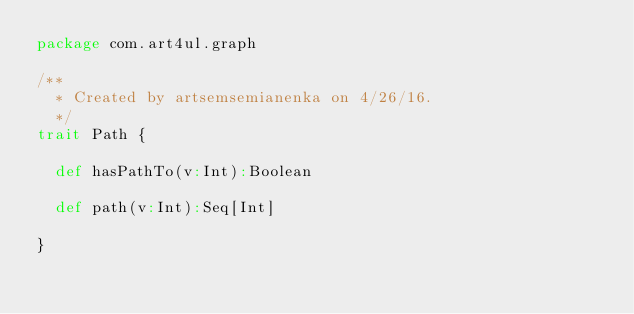Convert code to text. <code><loc_0><loc_0><loc_500><loc_500><_Scala_>package com.art4ul.graph

/**
  * Created by artsemsemianenka on 4/26/16.
  */
trait Path {

  def hasPathTo(v:Int):Boolean

  def path(v:Int):Seq[Int]

}
</code> 